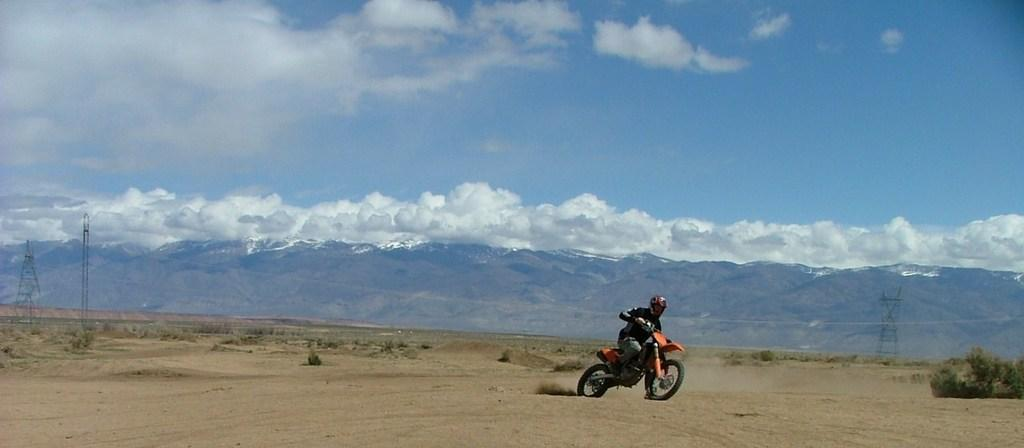What type of terrain is visible in the image? There is grass and hills visible in the image. What structures can be seen in the image? Current poles are present in the image. What is the man in the image doing? The man is riding a motorcycle in the image. What is visible in the sky in the image? The sky is visible in the image, and clouds are present. What type of liquid is being transported by the coal truck in the image? There is no coal truck or liquid present in the image. What type of road is the motorcycle riding on in the image? The image does not show a road; it shows grass and hills. 